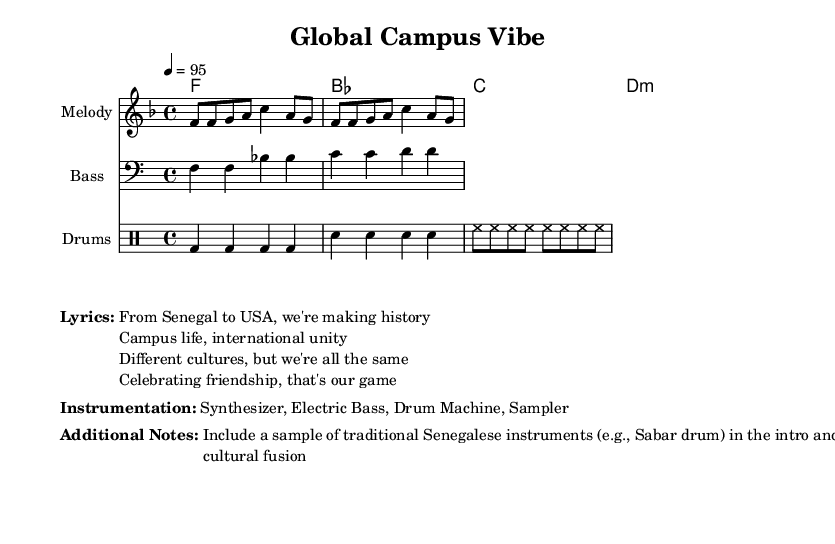What is the key signature of this music? The key signature is F major, which has one flat (B flat). This is indicated at the beginning of the staff where the key signature is shown.
Answer: F major What is the time signature of this music? The time signature shown at the beginning of the music is 4/4, which means there are four beats per measure and a quarter note gets one beat. This is indicated next to the clef at the start of the piece.
Answer: 4/4 What is the tempo marking for the piece? The tempo marking is quarter note equals 95, which indicates that each quarter note should be played at a speed of 95 beats per minute. This is typically found in the first sections of the score, near the time signature.
Answer: 95 How many measures are in the melody section? The melody section contains 4 measures, which can be counted based on the vertical lines that separate each measure in the staff.
Answer: 4 What is the primary genre of this piece? The primary genre is rap, as indicated by the content and style described, including upbeat party themes and international friendships. This is contextually deduced from the lyrics and the overall composition intent.
Answer: Rap What additional instruments are suggested for cultural fusion? The suggested additional instrument is the Sabar drum, a traditional Senegalese instrument, referenced in the additional notes that mention including it in the intro and breaks for cultural fusion.
Answer: Sabar drum 